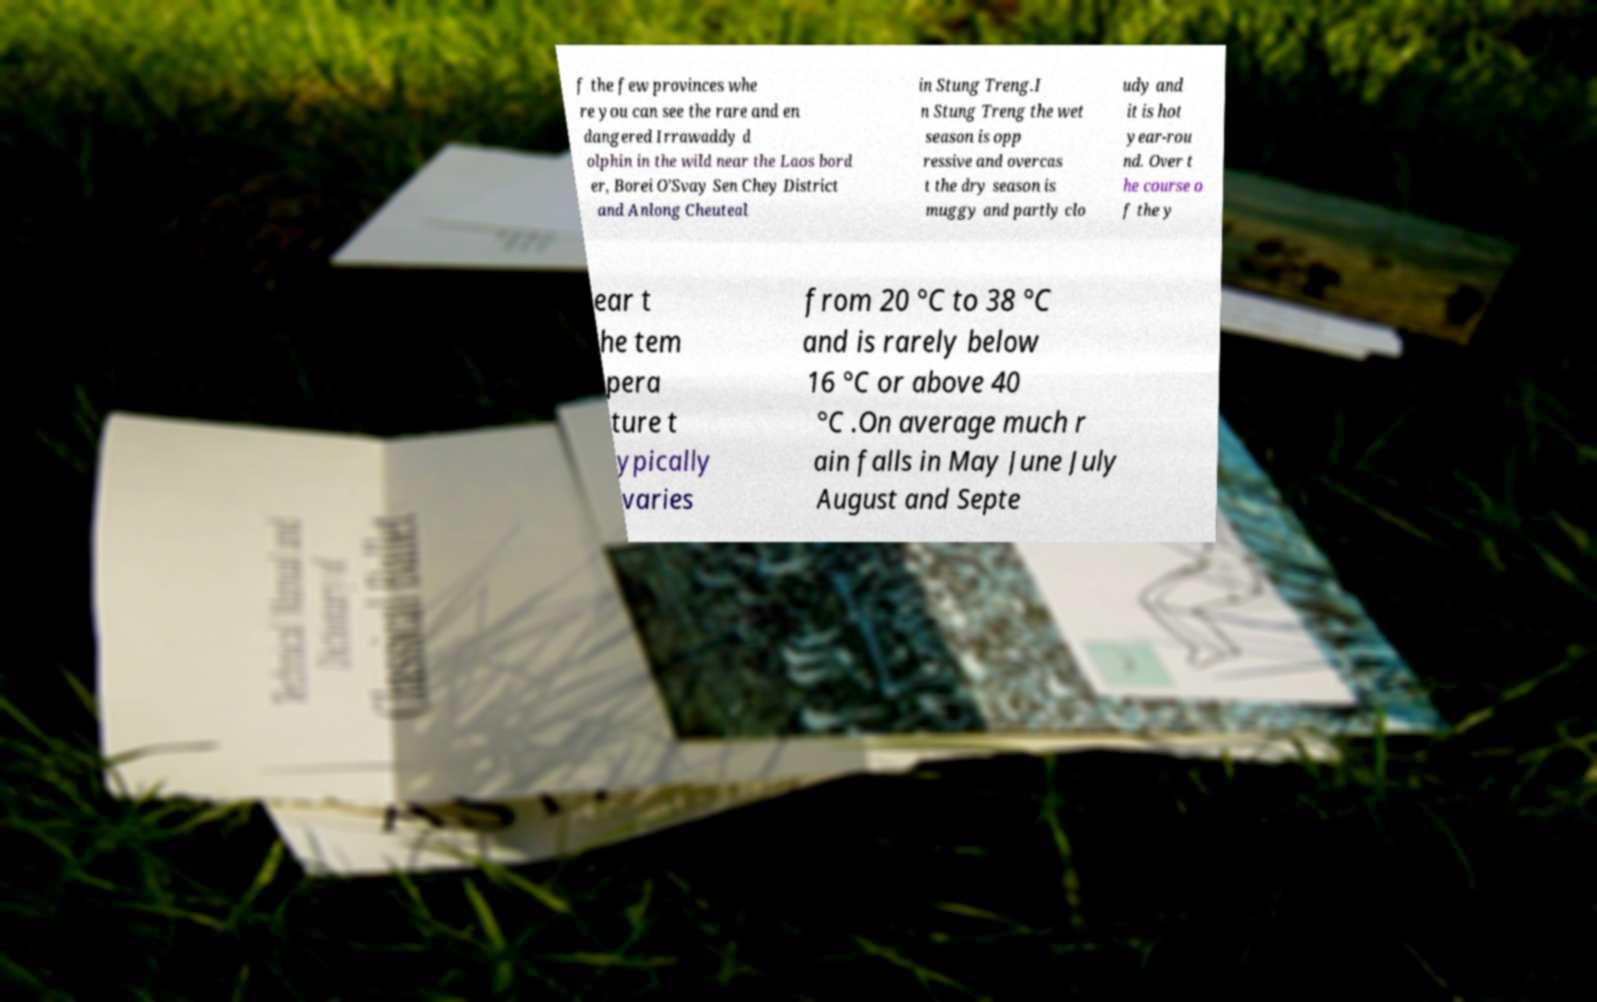For documentation purposes, I need the text within this image transcribed. Could you provide that? f the few provinces whe re you can see the rare and en dangered Irrawaddy d olphin in the wild near the Laos bord er, Borei O’Svay Sen Chey District and Anlong Cheuteal in Stung Treng.I n Stung Treng the wet season is opp ressive and overcas t the dry season is muggy and partly clo udy and it is hot year-rou nd. Over t he course o f the y ear t he tem pera ture t ypically varies from 20 °C to 38 °C and is rarely below 16 °C or above 40 °C .On average much r ain falls in May June July August and Septe 